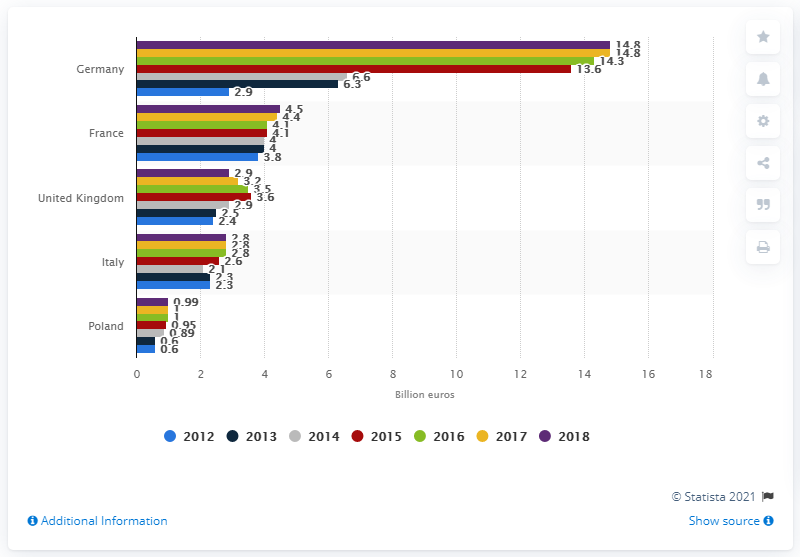Highlight a few significant elements in this photo. In 2018, France's direct selling market generated approximately 4.5 billion euros. 